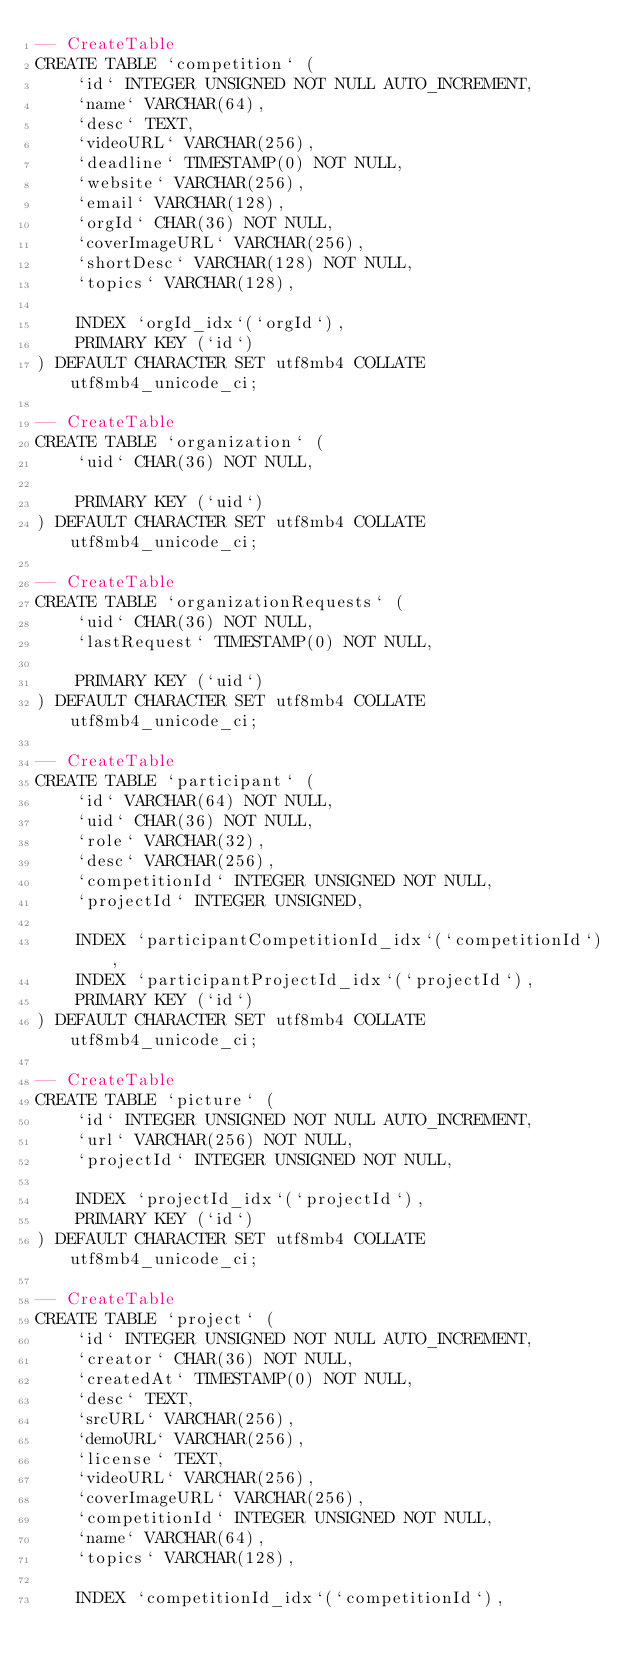<code> <loc_0><loc_0><loc_500><loc_500><_SQL_>-- CreateTable
CREATE TABLE `competition` (
    `id` INTEGER UNSIGNED NOT NULL AUTO_INCREMENT,
    `name` VARCHAR(64),
    `desc` TEXT,
    `videoURL` VARCHAR(256),
    `deadline` TIMESTAMP(0) NOT NULL,
    `website` VARCHAR(256),
    `email` VARCHAR(128),
    `orgId` CHAR(36) NOT NULL,
    `coverImageURL` VARCHAR(256),
    `shortDesc` VARCHAR(128) NOT NULL,
    `topics` VARCHAR(128),

    INDEX `orgId_idx`(`orgId`),
    PRIMARY KEY (`id`)
) DEFAULT CHARACTER SET utf8mb4 COLLATE utf8mb4_unicode_ci;

-- CreateTable
CREATE TABLE `organization` (
    `uid` CHAR(36) NOT NULL,

    PRIMARY KEY (`uid`)
) DEFAULT CHARACTER SET utf8mb4 COLLATE utf8mb4_unicode_ci;

-- CreateTable
CREATE TABLE `organizationRequests` (
    `uid` CHAR(36) NOT NULL,
    `lastRequest` TIMESTAMP(0) NOT NULL,

    PRIMARY KEY (`uid`)
) DEFAULT CHARACTER SET utf8mb4 COLLATE utf8mb4_unicode_ci;

-- CreateTable
CREATE TABLE `participant` (
    `id` VARCHAR(64) NOT NULL,
    `uid` CHAR(36) NOT NULL,
    `role` VARCHAR(32),
    `desc` VARCHAR(256),
    `competitionId` INTEGER UNSIGNED NOT NULL,
    `projectId` INTEGER UNSIGNED,

    INDEX `participantCompetitionId_idx`(`competitionId`),
    INDEX `participantProjectId_idx`(`projectId`),
    PRIMARY KEY (`id`)
) DEFAULT CHARACTER SET utf8mb4 COLLATE utf8mb4_unicode_ci;

-- CreateTable
CREATE TABLE `picture` (
    `id` INTEGER UNSIGNED NOT NULL AUTO_INCREMENT,
    `url` VARCHAR(256) NOT NULL,
    `projectId` INTEGER UNSIGNED NOT NULL,

    INDEX `projectId_idx`(`projectId`),
    PRIMARY KEY (`id`)
) DEFAULT CHARACTER SET utf8mb4 COLLATE utf8mb4_unicode_ci;

-- CreateTable
CREATE TABLE `project` (
    `id` INTEGER UNSIGNED NOT NULL AUTO_INCREMENT,
    `creator` CHAR(36) NOT NULL,
    `createdAt` TIMESTAMP(0) NOT NULL,
    `desc` TEXT,
    `srcURL` VARCHAR(256),
    `demoURL` VARCHAR(256),
    `license` TEXT,
    `videoURL` VARCHAR(256),
    `coverImageURL` VARCHAR(256),
    `competitionId` INTEGER UNSIGNED NOT NULL,
    `name` VARCHAR(64),
    `topics` VARCHAR(128),

    INDEX `competitionId_idx`(`competitionId`),</code> 